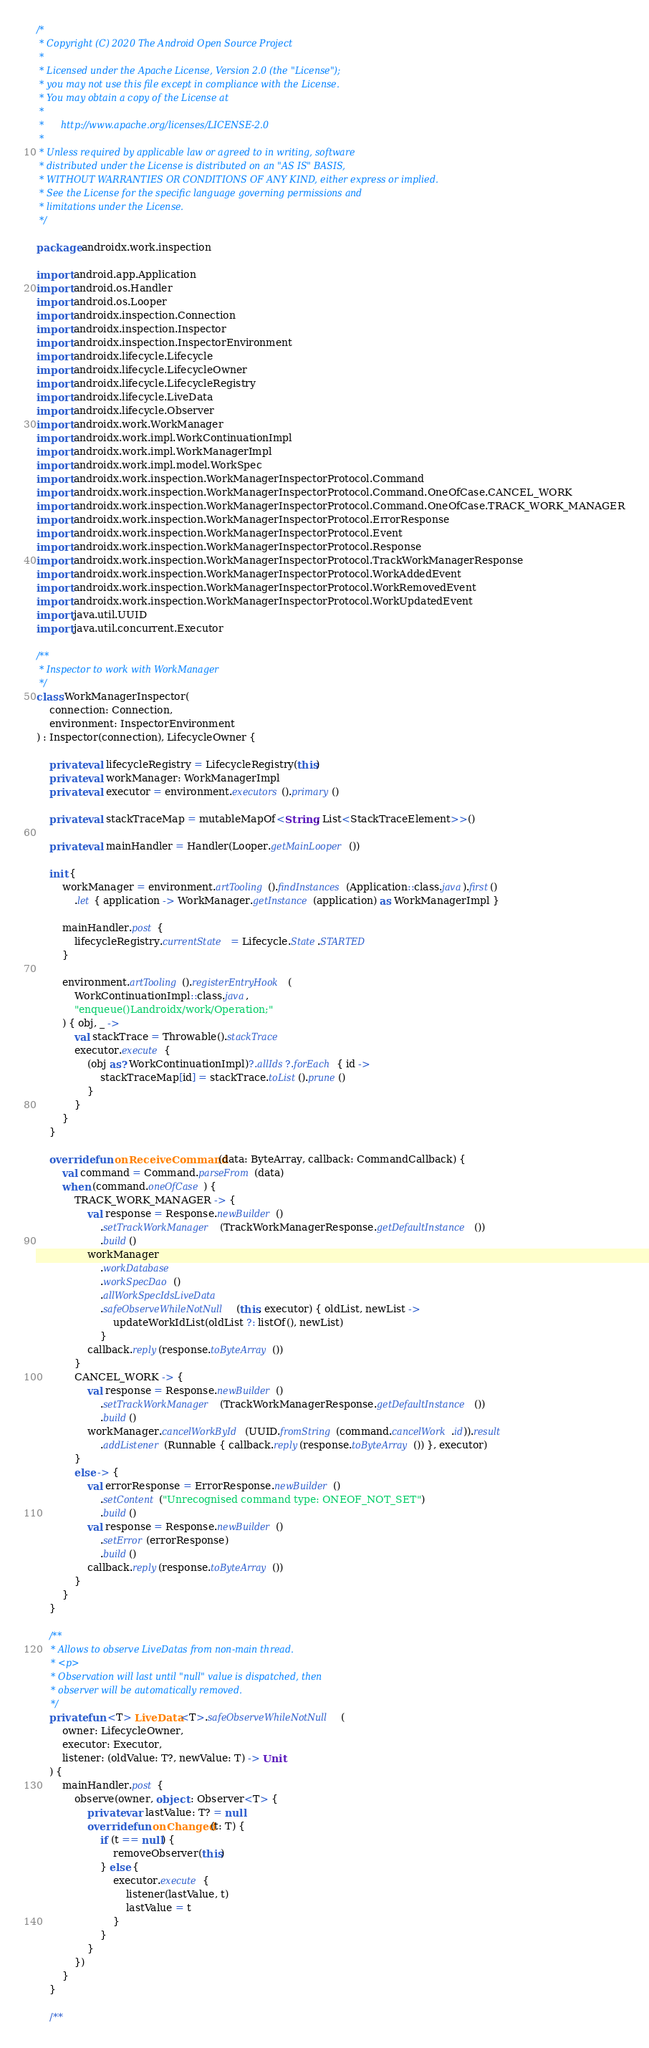<code> <loc_0><loc_0><loc_500><loc_500><_Kotlin_>/*
 * Copyright (C) 2020 The Android Open Source Project
 *
 * Licensed under the Apache License, Version 2.0 (the "License");
 * you may not use this file except in compliance with the License.
 * You may obtain a copy of the License at
 *
 *      http://www.apache.org/licenses/LICENSE-2.0
 *
 * Unless required by applicable law or agreed to in writing, software
 * distributed under the License is distributed on an "AS IS" BASIS,
 * WITHOUT WARRANTIES OR CONDITIONS OF ANY KIND, either express or implied.
 * See the License for the specific language governing permissions and
 * limitations under the License.
 */

package androidx.work.inspection

import android.app.Application
import android.os.Handler
import android.os.Looper
import androidx.inspection.Connection
import androidx.inspection.Inspector
import androidx.inspection.InspectorEnvironment
import androidx.lifecycle.Lifecycle
import androidx.lifecycle.LifecycleOwner
import androidx.lifecycle.LifecycleRegistry
import androidx.lifecycle.LiveData
import androidx.lifecycle.Observer
import androidx.work.WorkManager
import androidx.work.impl.WorkContinuationImpl
import androidx.work.impl.WorkManagerImpl
import androidx.work.impl.model.WorkSpec
import androidx.work.inspection.WorkManagerInspectorProtocol.Command
import androidx.work.inspection.WorkManagerInspectorProtocol.Command.OneOfCase.CANCEL_WORK
import androidx.work.inspection.WorkManagerInspectorProtocol.Command.OneOfCase.TRACK_WORK_MANAGER
import androidx.work.inspection.WorkManagerInspectorProtocol.ErrorResponse
import androidx.work.inspection.WorkManagerInspectorProtocol.Event
import androidx.work.inspection.WorkManagerInspectorProtocol.Response
import androidx.work.inspection.WorkManagerInspectorProtocol.TrackWorkManagerResponse
import androidx.work.inspection.WorkManagerInspectorProtocol.WorkAddedEvent
import androidx.work.inspection.WorkManagerInspectorProtocol.WorkRemovedEvent
import androidx.work.inspection.WorkManagerInspectorProtocol.WorkUpdatedEvent
import java.util.UUID
import java.util.concurrent.Executor

/**
 * Inspector to work with WorkManager
 */
class WorkManagerInspector(
    connection: Connection,
    environment: InspectorEnvironment
) : Inspector(connection), LifecycleOwner {

    private val lifecycleRegistry = LifecycleRegistry(this)
    private val workManager: WorkManagerImpl
    private val executor = environment.executors().primary()

    private val stackTraceMap = mutableMapOf<String, List<StackTraceElement>>()

    private val mainHandler = Handler(Looper.getMainLooper())

    init {
        workManager = environment.artTooling().findInstances(Application::class.java).first()
            .let { application -> WorkManager.getInstance(application) as WorkManagerImpl }

        mainHandler.post {
            lifecycleRegistry.currentState = Lifecycle.State.STARTED
        }

        environment.artTooling().registerEntryHook(
            WorkContinuationImpl::class.java,
            "enqueue()Landroidx/work/Operation;"
        ) { obj, _ ->
            val stackTrace = Throwable().stackTrace
            executor.execute {
                (obj as? WorkContinuationImpl)?.allIds?.forEach { id ->
                    stackTraceMap[id] = stackTrace.toList().prune()
                }
            }
        }
    }

    override fun onReceiveCommand(data: ByteArray, callback: CommandCallback) {
        val command = Command.parseFrom(data)
        when (command.oneOfCase) {
            TRACK_WORK_MANAGER -> {
                val response = Response.newBuilder()
                    .setTrackWorkManager(TrackWorkManagerResponse.getDefaultInstance())
                    .build()
                workManager
                    .workDatabase
                    .workSpecDao()
                    .allWorkSpecIdsLiveData
                    .safeObserveWhileNotNull(this, executor) { oldList, newList ->
                        updateWorkIdList(oldList ?: listOf(), newList)
                    }
                callback.reply(response.toByteArray())
            }
            CANCEL_WORK -> {
                val response = Response.newBuilder()
                    .setTrackWorkManager(TrackWorkManagerResponse.getDefaultInstance())
                    .build()
                workManager.cancelWorkById(UUID.fromString(command.cancelWork.id)).result
                    .addListener(Runnable { callback.reply(response.toByteArray()) }, executor)
            }
            else -> {
                val errorResponse = ErrorResponse.newBuilder()
                    .setContent("Unrecognised command type: ONEOF_NOT_SET")
                    .build()
                val response = Response.newBuilder()
                    .setError(errorResponse)
                    .build()
                callback.reply(response.toByteArray())
            }
        }
    }

    /**
     * Allows to observe LiveDatas from non-main thread.
     * <p>
     * Observation will last until "null" value is dispatched, then
     * observer will be automatically removed.
     */
    private fun <T> LiveData<T>.safeObserveWhileNotNull(
        owner: LifecycleOwner,
        executor: Executor,
        listener: (oldValue: T?, newValue: T) -> Unit
    ) {
        mainHandler.post {
            observe(owner, object : Observer<T> {
                private var lastValue: T? = null
                override fun onChanged(t: T) {
                    if (t == null) {
                        removeObserver(this)
                    } else {
                        executor.execute {
                            listener(lastValue, t)
                            lastValue = t
                        }
                    }
                }
            })
        }
    }

    /**</code> 